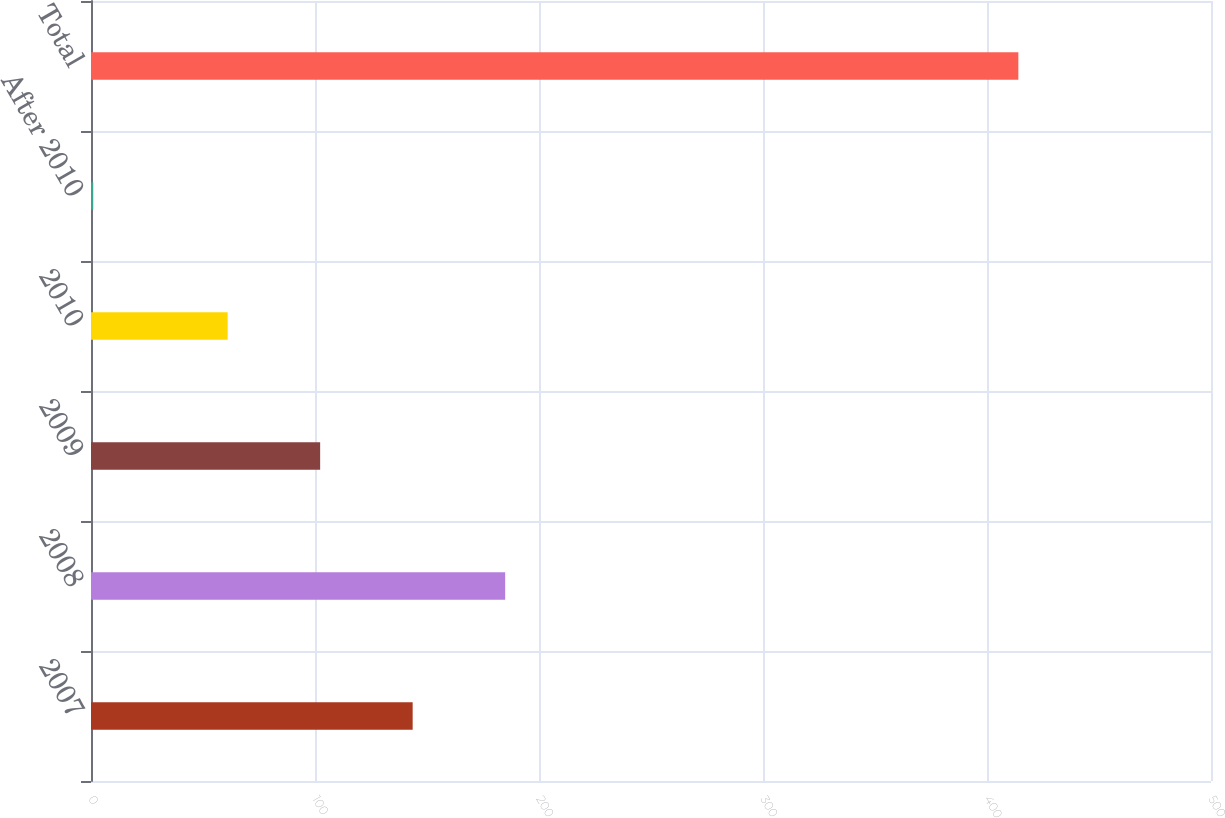Convert chart. <chart><loc_0><loc_0><loc_500><loc_500><bar_chart><fcel>2007<fcel>2008<fcel>2009<fcel>2010<fcel>After 2010<fcel>Total<nl><fcel>143.6<fcel>184.9<fcel>102.3<fcel>61<fcel>1<fcel>414<nl></chart> 